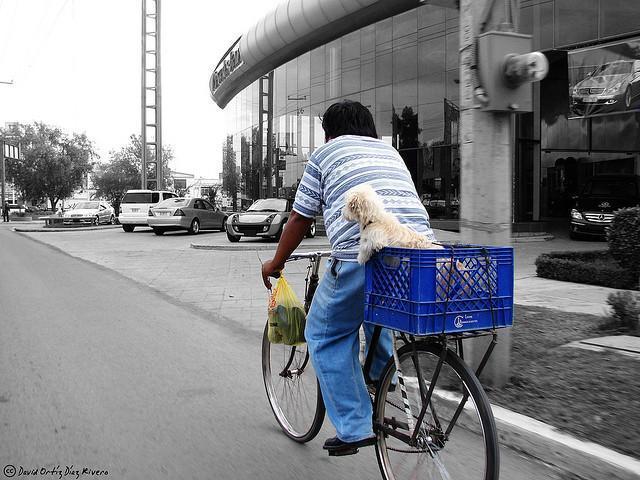How many people are there?
Give a very brief answer. 1. How many cars can be seen?
Give a very brief answer. 4. 